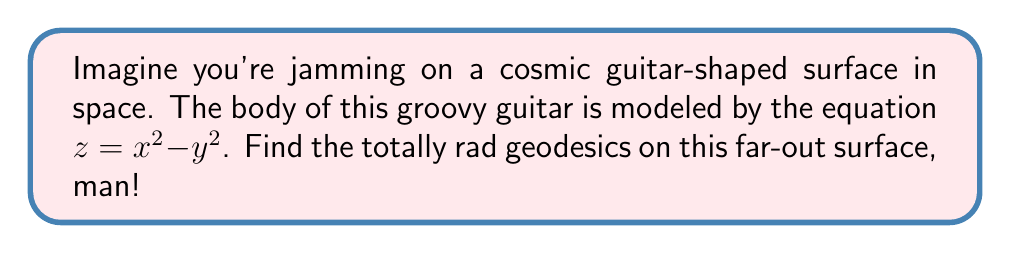Can you answer this question? Alright, let's break this down step-by-step, like a smooth drum solo:

1) First, we need to set up the metric for our guitar-shaped surface. The surface is given by $z = x^2 - y^2$. We can parameterize this surface as:

   $\mathbf{r}(x,y) = (x, y, x^2 - y^2)$

2) To find the metric, we need to calculate the partial derivatives:

   $\mathbf{r}_x = (1, 0, 2x)$
   $\mathbf{r}_y = (0, 1, -2y)$

3) Now, we can compute the components of the metric tensor:

   $g_{11} = \mathbf{r}_x \cdot \mathbf{r}_x = 1 + 4x^2$
   $g_{12} = g_{21} = \mathbf{r}_x \cdot \mathbf{r}_y = 0$
   $g_{22} = \mathbf{r}_y \cdot \mathbf{r}_y = 1 + 4y^2$

4) The geodesic equations are given by:

   $$\frac{d^2x^i}{dt^2} + \Gamma^i_{jk}\frac{dx^j}{dt}\frac{dx^k}{dt} = 0$$

   Where $\Gamma^i_{jk}$ are the Christoffel symbols.

5) We need to calculate the Christoffel symbols. The non-zero symbols are:

   $\Gamma^1_{11} = \frac{4x}{1+4x^2}$
   $\Gamma^2_{22} = \frac{4y}{1+4y^2}$
   $\Gamma^3_{11} = 2$
   $\Gamma^3_{22} = -2$

6) Substituting these into the geodesic equations:

   $$\frac{d^2x}{dt^2} + \frac{4x}{1+4x^2}\left(\frac{dx}{dt}\right)^2 = 0$$
   $$\frac{d^2y}{dt^2} + \frac{4y}{1+4y^2}\left(\frac{dy}{dt}\right)^2 = 0$$
   $$\frac{d^2z}{dt^2} + 2\left(\frac{dx}{dt}\right)^2 - 2\left(\frac{dy}{dt}\right)^2 = 0$$

7) These equations describe the geodesics on our guitar-shaped surface. They're like the cosmic melody lines that follow the curvature of our space guitar!

8) In general, these equations don't have a simple closed-form solution. They would typically be solved numerically for specific initial conditions.

9) However, we can identify some special cases:

   - When $x$ is constant, the geodesics are parabolas in the $y-z$ plane.
   - When $y$ is constant, the geodesics are parabolas in the $x-z$ plane.
   - The lines where $x = \pm y$ are also geodesics.
Answer: The geodesics are described by the system of differential equations:

$$\frac{d^2x}{dt^2} + \frac{4x}{1+4x^2}\left(\frac{dx}{dt}\right)^2 = 0$$
$$\frac{d^2y}{dt^2} + \frac{4y}{1+4y^2}\left(\frac{dy}{dt}\right)^2 = 0$$
$$\frac{d^2z}{dt^2} + 2\left(\frac{dx}{dt}\right)^2 - 2\left(\frac{dy}{dt}\right)^2 = 0$$ 